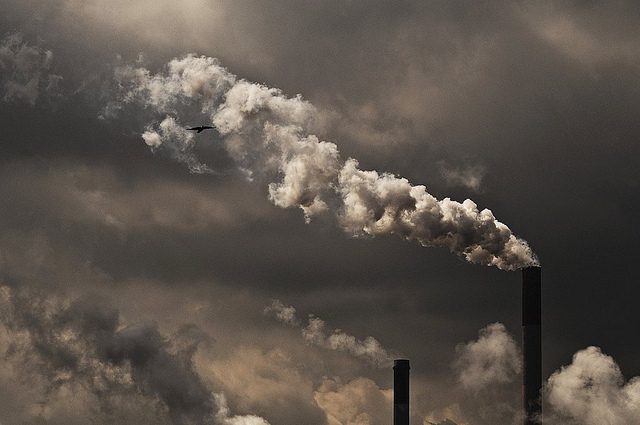<image>Where are the planes? I am not sure where the planes are, they might be in the sky or near smoke. Where are the planes? I don't know where the planes are. It can be seen in the sky, between the smokers or near the smoke. 